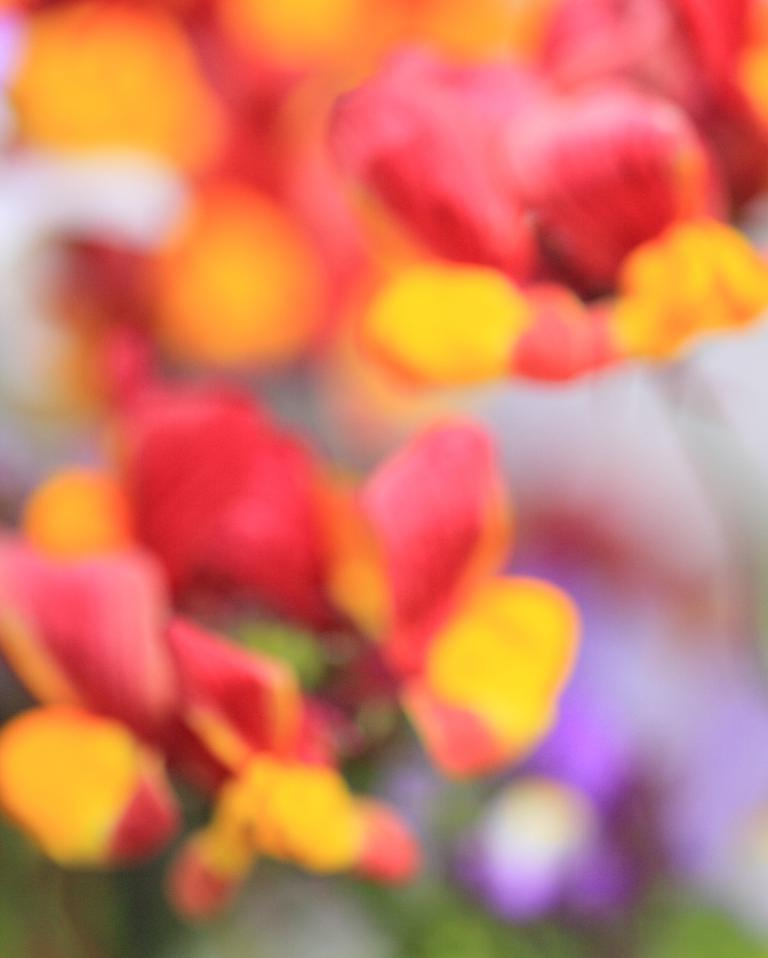What type of living organisms can be seen in the image? There are flowers in the image. What colors are the flowers in the image? The flowers are in red and yellow colors. How many dolls are sitting on the swing in the image? There are no dolls or swings present in the image; it features flowers in red and yellow colors. 